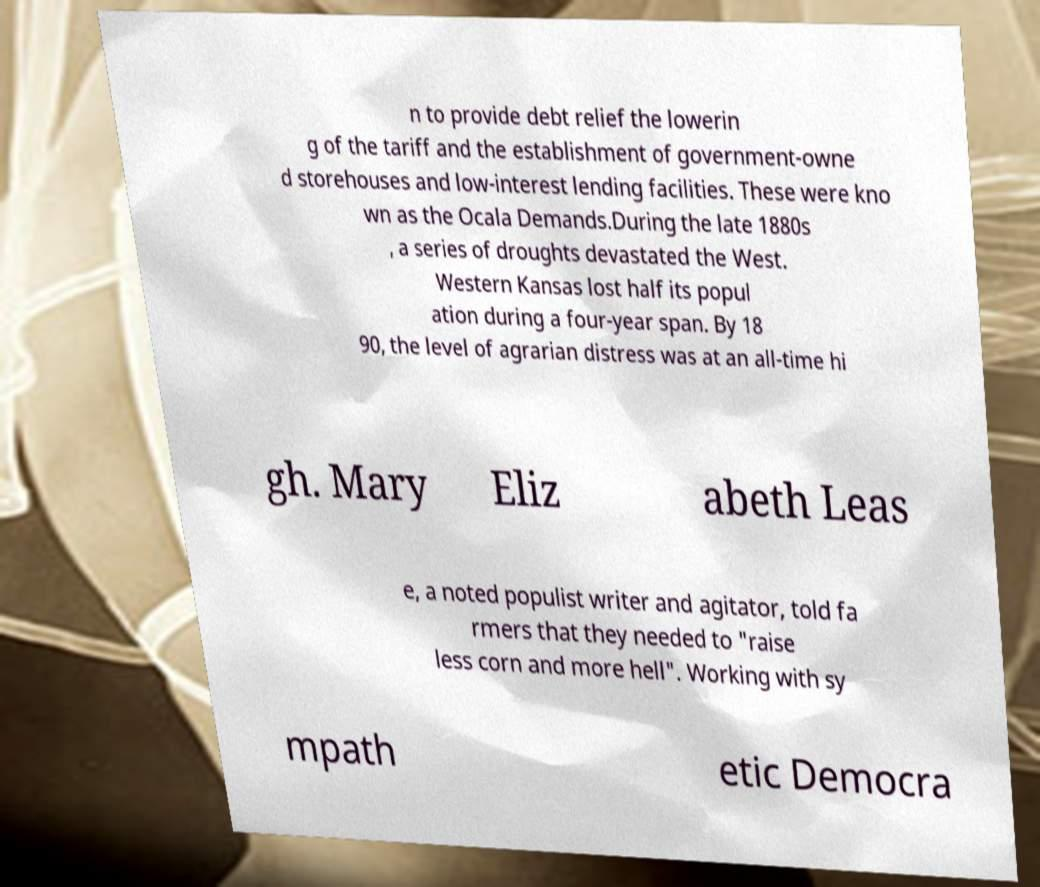Please identify and transcribe the text found in this image. n to provide debt relief the lowerin g of the tariff and the establishment of government-owne d storehouses and low-interest lending facilities. These were kno wn as the Ocala Demands.During the late 1880s , a series of droughts devastated the West. Western Kansas lost half its popul ation during a four-year span. By 18 90, the level of agrarian distress was at an all-time hi gh. Mary Eliz abeth Leas e, a noted populist writer and agitator, told fa rmers that they needed to "raise less corn and more hell". Working with sy mpath etic Democra 